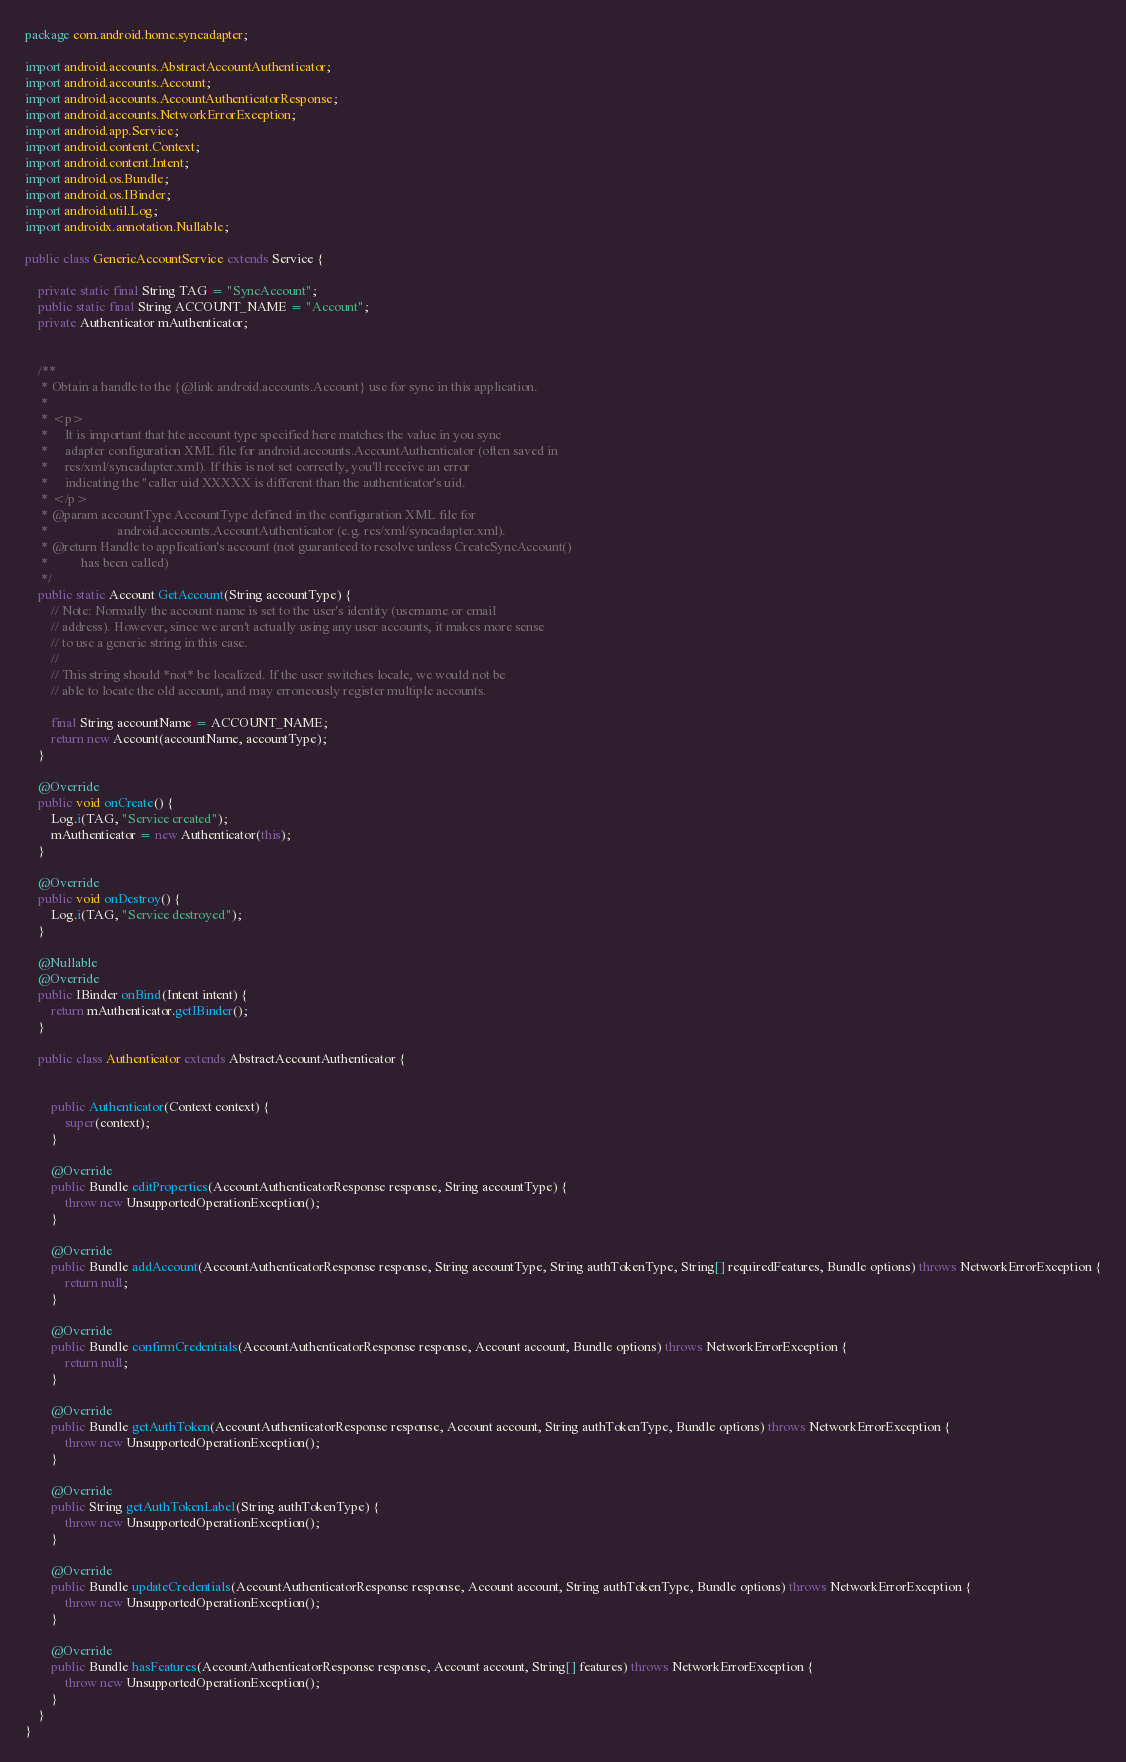Convert code to text. <code><loc_0><loc_0><loc_500><loc_500><_Java_>package com.android.home.syncadapter;

import android.accounts.AbstractAccountAuthenticator;
import android.accounts.Account;
import android.accounts.AccountAuthenticatorResponse;
import android.accounts.NetworkErrorException;
import android.app.Service;
import android.content.Context;
import android.content.Intent;
import android.os.Bundle;
import android.os.IBinder;
import android.util.Log;
import androidx.annotation.Nullable;

public class GenericAccountService extends Service {

    private static final String TAG = "SyncAccount";
    public static final String ACCOUNT_NAME = "Account";
    private Authenticator mAuthenticator;


    /**
     * Obtain a handle to the {@link android.accounts.Account} use for sync in this application.
     *
     * <p>
     *     It is important that hte account type specified here matches the value in you sync
     *     adapter configuration XML file for android.accounts.AccountAuthenticator (often saved in
     *     res/xml/syncadapter.xml). If this is not set correctly, you'll receive an error
     *     indicating the "caller uid XXXXX is different than the authenticator's uid.
     * </p>
     * @param accountType AccountType defined in the configuration XML file for
     *                     android.accounts.AccountAuthenticator (e.g. res/xml/syncadapter.xml).
     * @return Handle to application's account (not guaranteed to resolve unless CreateSyncAccount()
     *          has been called)
     */
    public static Account GetAccount(String accountType) {
        // Note: Normally the account name is set to the user's identity (username or email
        // address). However, since we aren't actually using any user accounts, it makes more sense
        // to use a generic string in this case.
        //
        // This string should *not* be localized. If the user switches locale, we would not be
        // able to locate the old account, and may erroneously register multiple accounts.

        final String accountName = ACCOUNT_NAME;
        return new Account(accountName, accountType);
    }

    @Override
    public void onCreate() {
        Log.i(TAG, "Service created");
        mAuthenticator = new Authenticator(this);
    }

    @Override
    public void onDestroy() {
        Log.i(TAG, "Service destroyed");
    }

    @Nullable
    @Override
    public IBinder onBind(Intent intent) {
        return mAuthenticator.getIBinder();
    }

    public class Authenticator extends AbstractAccountAuthenticator {


        public Authenticator(Context context) {
            super(context);
        }

        @Override
        public Bundle editProperties(AccountAuthenticatorResponse response, String accountType) {
            throw new UnsupportedOperationException();
        }

        @Override
        public Bundle addAccount(AccountAuthenticatorResponse response, String accountType, String authTokenType, String[] requiredFeatures, Bundle options) throws NetworkErrorException {
            return null;
        }

        @Override
        public Bundle confirmCredentials(AccountAuthenticatorResponse response, Account account, Bundle options) throws NetworkErrorException {
            return null;
        }

        @Override
        public Bundle getAuthToken(AccountAuthenticatorResponse response, Account account, String authTokenType, Bundle options) throws NetworkErrorException {
            throw new UnsupportedOperationException();
        }

        @Override
        public String getAuthTokenLabel(String authTokenType) {
            throw new UnsupportedOperationException();
        }

        @Override
        public Bundle updateCredentials(AccountAuthenticatorResponse response, Account account, String authTokenType, Bundle options) throws NetworkErrorException {
            throw new UnsupportedOperationException();
        }

        @Override
        public Bundle hasFeatures(AccountAuthenticatorResponse response, Account account, String[] features) throws NetworkErrorException {
            throw new UnsupportedOperationException();
        }
    }
}
</code> 